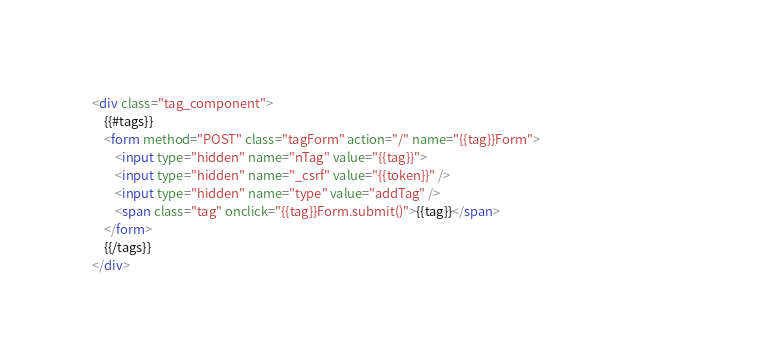Convert code to text. <code><loc_0><loc_0><loc_500><loc_500><_HTML_><div class="tag_component">
	{{#tags}}
	<form method="POST" class="tagForm" action="/" name="{{tag}}Form">
		<input type="hidden" name="nTag" value="{{tag}}"> 
		<input type="hidden" name="_csrf" value="{{token}}" /> 
		<input type="hidden" name="type" value="addTag" /> 
		<span class="tag" onclick="{{tag}}Form.submit()">{{tag}}</span>																
	</form>							
	{{/tags}}  
</div>      </code> 